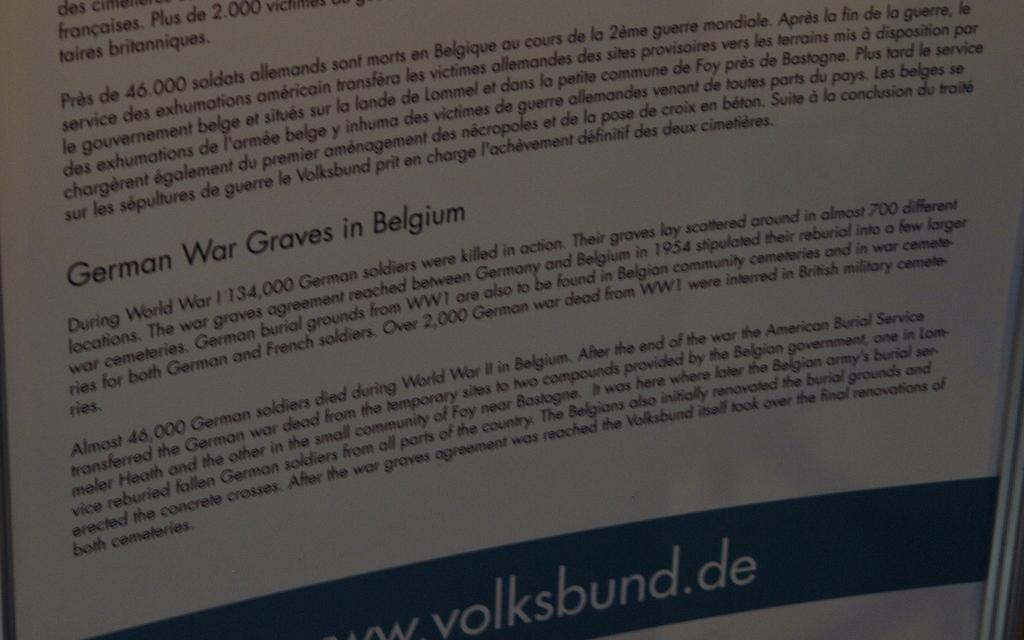<image>
Relay a brief, clear account of the picture shown. Page with the words "German War Graves in Belgium" in the middle. 